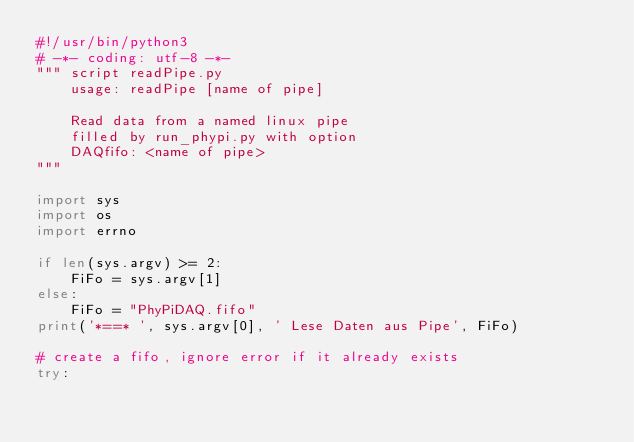Convert code to text. <code><loc_0><loc_0><loc_500><loc_500><_Python_>#!/usr/bin/python3
# -*- coding: utf-8 -*-
""" script readPipe.py
    usage: readPipe [name of pipe]

    Read data from a named linux pipe
    filled by run_phypi.py with option
    DAQfifo: <name of pipe>
"""

import sys
import os
import errno

if len(sys.argv) >= 2:
    FiFo = sys.argv[1]
else:
    FiFo = "PhyPiDAQ.fifo"
print('*==* ', sys.argv[0], ' Lese Daten aus Pipe', FiFo)

# create a fifo, ignore error if it already exists
try:</code> 